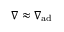<formula> <loc_0><loc_0><loc_500><loc_500>\nabla \approx \nabla _ { a d }</formula> 